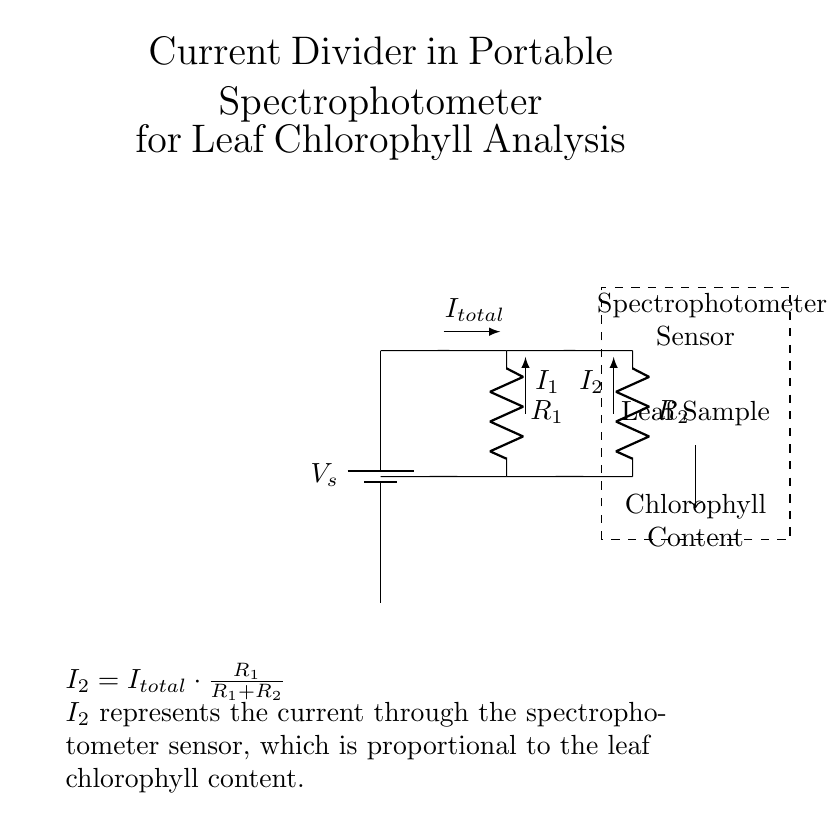What is the total current in this circuit? The total current in the circuit is labeled as I_total, indicating the collective current flowing from the power source through both resistors and the spectrophotometer.
Answer: I_total What does R1 represent in the circuit? R1 represents one of the resistors in the current divider, which contributes to dividing the total current between the two paths.
Answer: R1 What is I2 in relation to the spectrophotometer? I2 represents the current flowing through the spectrophotometer sensor, indicating that it is part of the parallel path providing a proportional output related to leaf chlorophyll analysis.
Answer: Current through spectrophotometer How is the current through the spectrophotometer (I2) calculated? The formula provided indicates that I2 can be calculated using the current division principle: I2 = I_total * (R1 / (R1 + R2)), taking into account the resistances in both branches.
Answer: I2 = I_total * (R1 / (R1 + R2)) What is the effect of increasing R1 on I2? Increasing R1 would increase the proportion of total current I2 due to the relationship defined by the current divider rule, which shows that as R1 rises, I2 also increases in relative terms.
Answer: I2 increases What components are involved in the circuit's operation? The components include a power supply (battery), two resistors R1 and R2, and a spectrophotometer sensor that measures chlorophyll content.
Answer: Battery, R1, R2, spectrophotometer What is the purpose of the dashed rectangle in the diagram? The dashed rectangle denotes the spectrophotometer sensor and the leaf sample, indicating where the analysis of chlorophyll content occurs within the circuit.
Answer: Represent spectrophotometer and leaf sample 